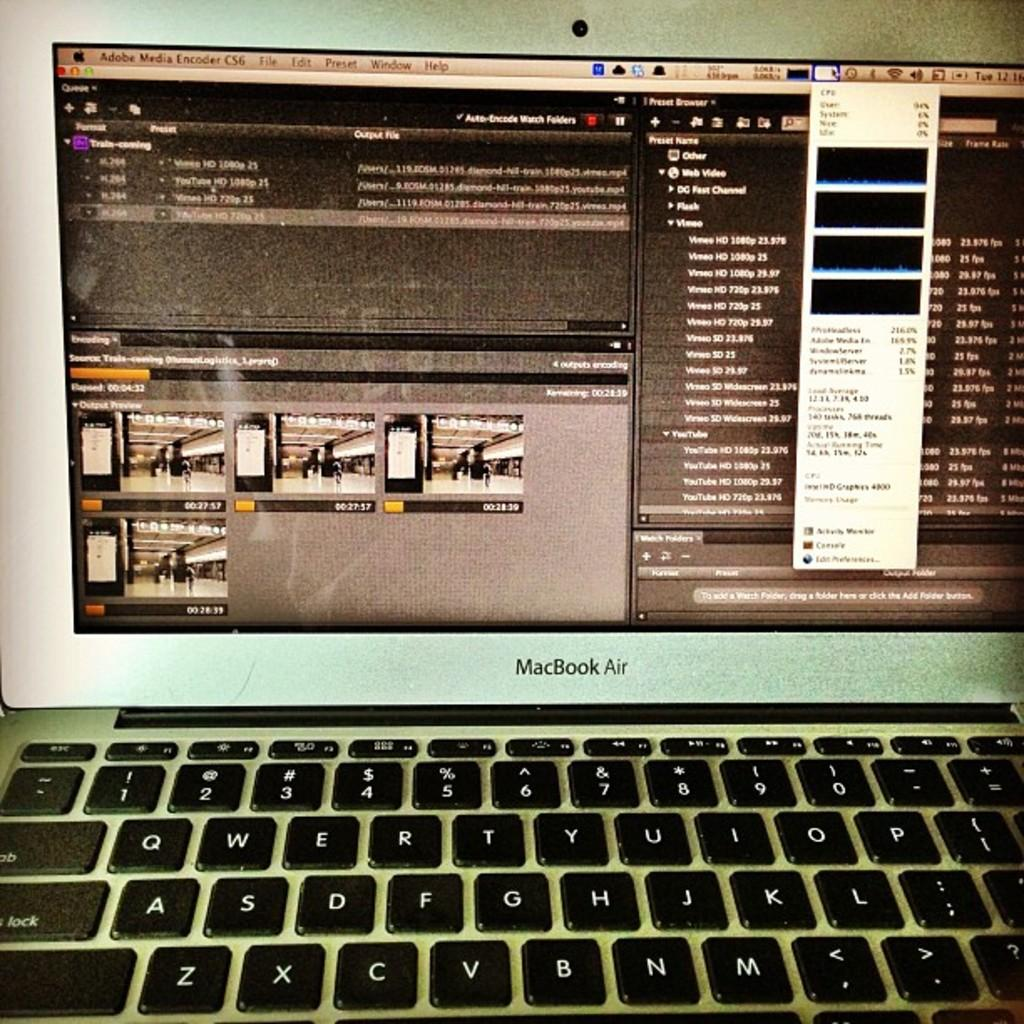<image>
Describe the image concisely. Part of an open and turned on MacBook Air. 